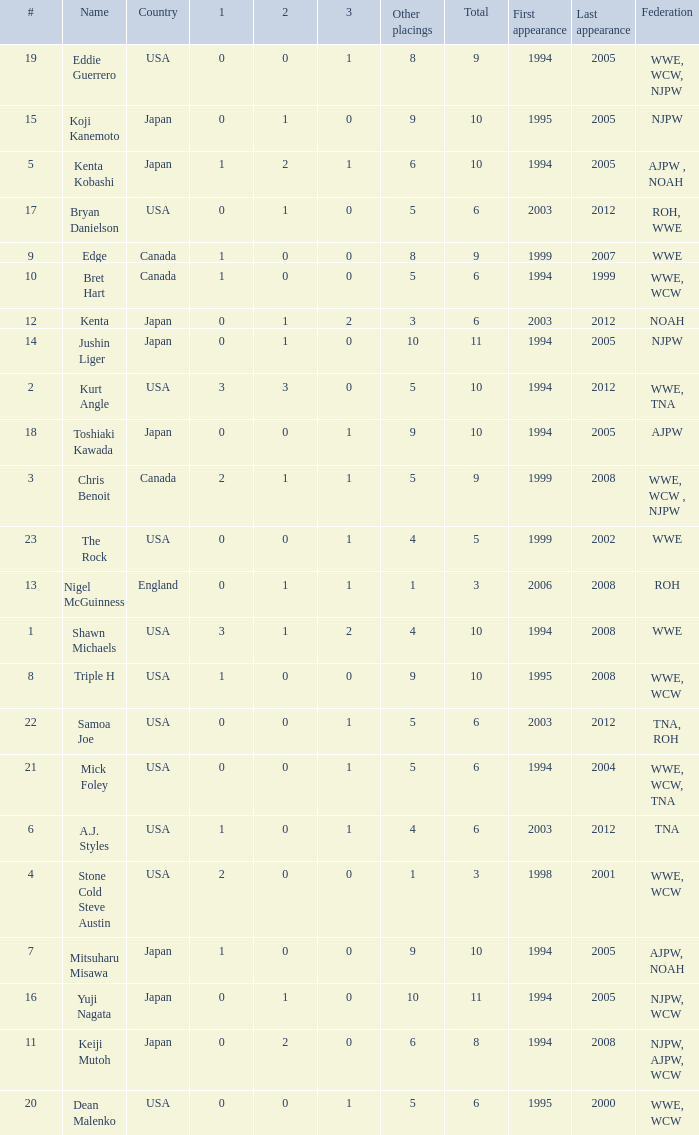How many times has a wrestler from the country of England wrestled in this event? 1.0. 